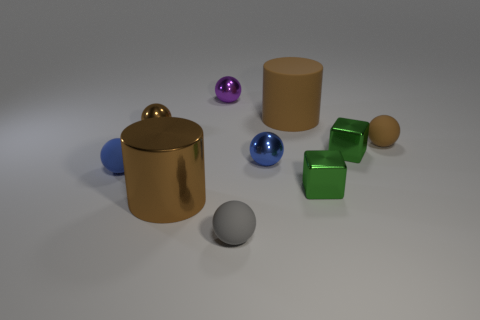Subtract 2 balls. How many balls are left? 4 Subtract all purple balls. How many balls are left? 5 Subtract all tiny brown matte spheres. How many spheres are left? 5 Subtract all red balls. Subtract all purple cylinders. How many balls are left? 6 Subtract all blocks. How many objects are left? 8 Subtract all tiny brown shiny spheres. Subtract all tiny gray matte objects. How many objects are left? 8 Add 8 blue metal things. How many blue metal things are left? 9 Add 9 tiny blue metallic objects. How many tiny blue metallic objects exist? 10 Subtract 0 purple cubes. How many objects are left? 10 